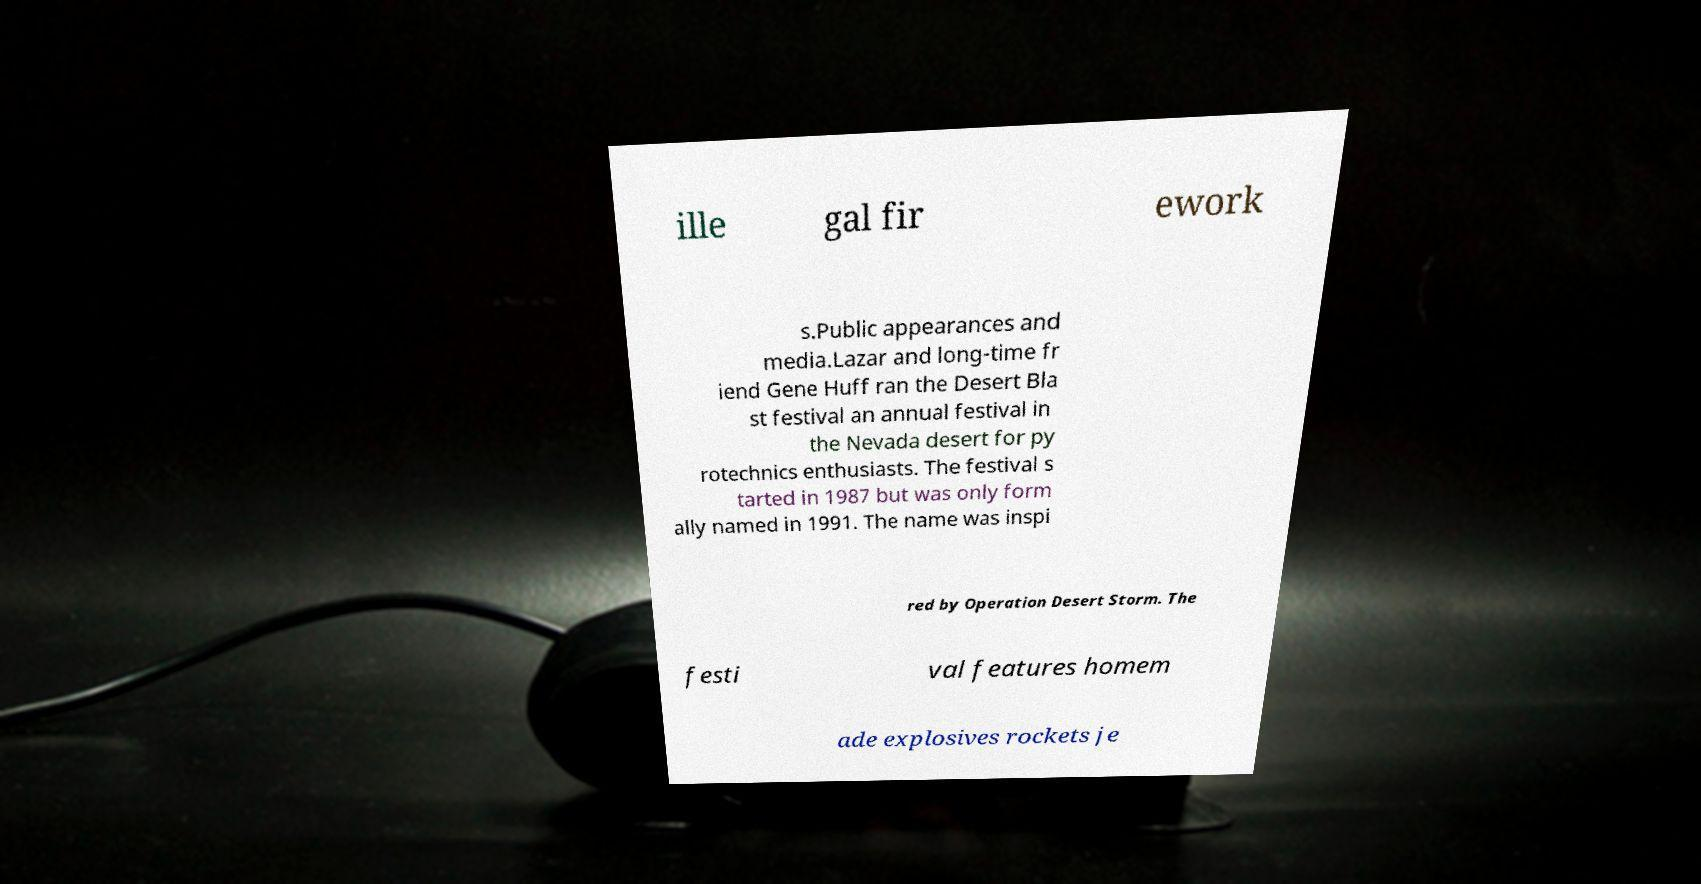For documentation purposes, I need the text within this image transcribed. Could you provide that? ille gal fir ework s.Public appearances and media.Lazar and long-time fr iend Gene Huff ran the Desert Bla st festival an annual festival in the Nevada desert for py rotechnics enthusiasts. The festival s tarted in 1987 but was only form ally named in 1991. The name was inspi red by Operation Desert Storm. The festi val features homem ade explosives rockets je 